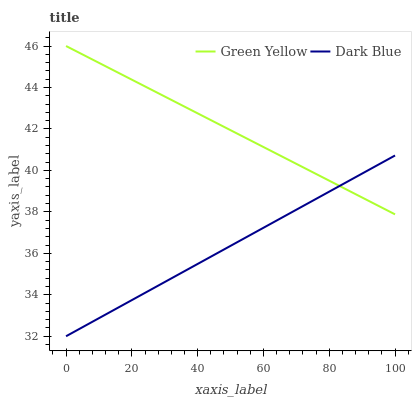Does Dark Blue have the minimum area under the curve?
Answer yes or no. Yes. Does Green Yellow have the maximum area under the curve?
Answer yes or no. Yes. Does Green Yellow have the minimum area under the curve?
Answer yes or no. No. Is Dark Blue the smoothest?
Answer yes or no. Yes. Is Green Yellow the roughest?
Answer yes or no. Yes. Does Dark Blue have the lowest value?
Answer yes or no. Yes. Does Green Yellow have the lowest value?
Answer yes or no. No. Does Green Yellow have the highest value?
Answer yes or no. Yes. Does Dark Blue intersect Green Yellow?
Answer yes or no. Yes. Is Dark Blue less than Green Yellow?
Answer yes or no. No. Is Dark Blue greater than Green Yellow?
Answer yes or no. No. 